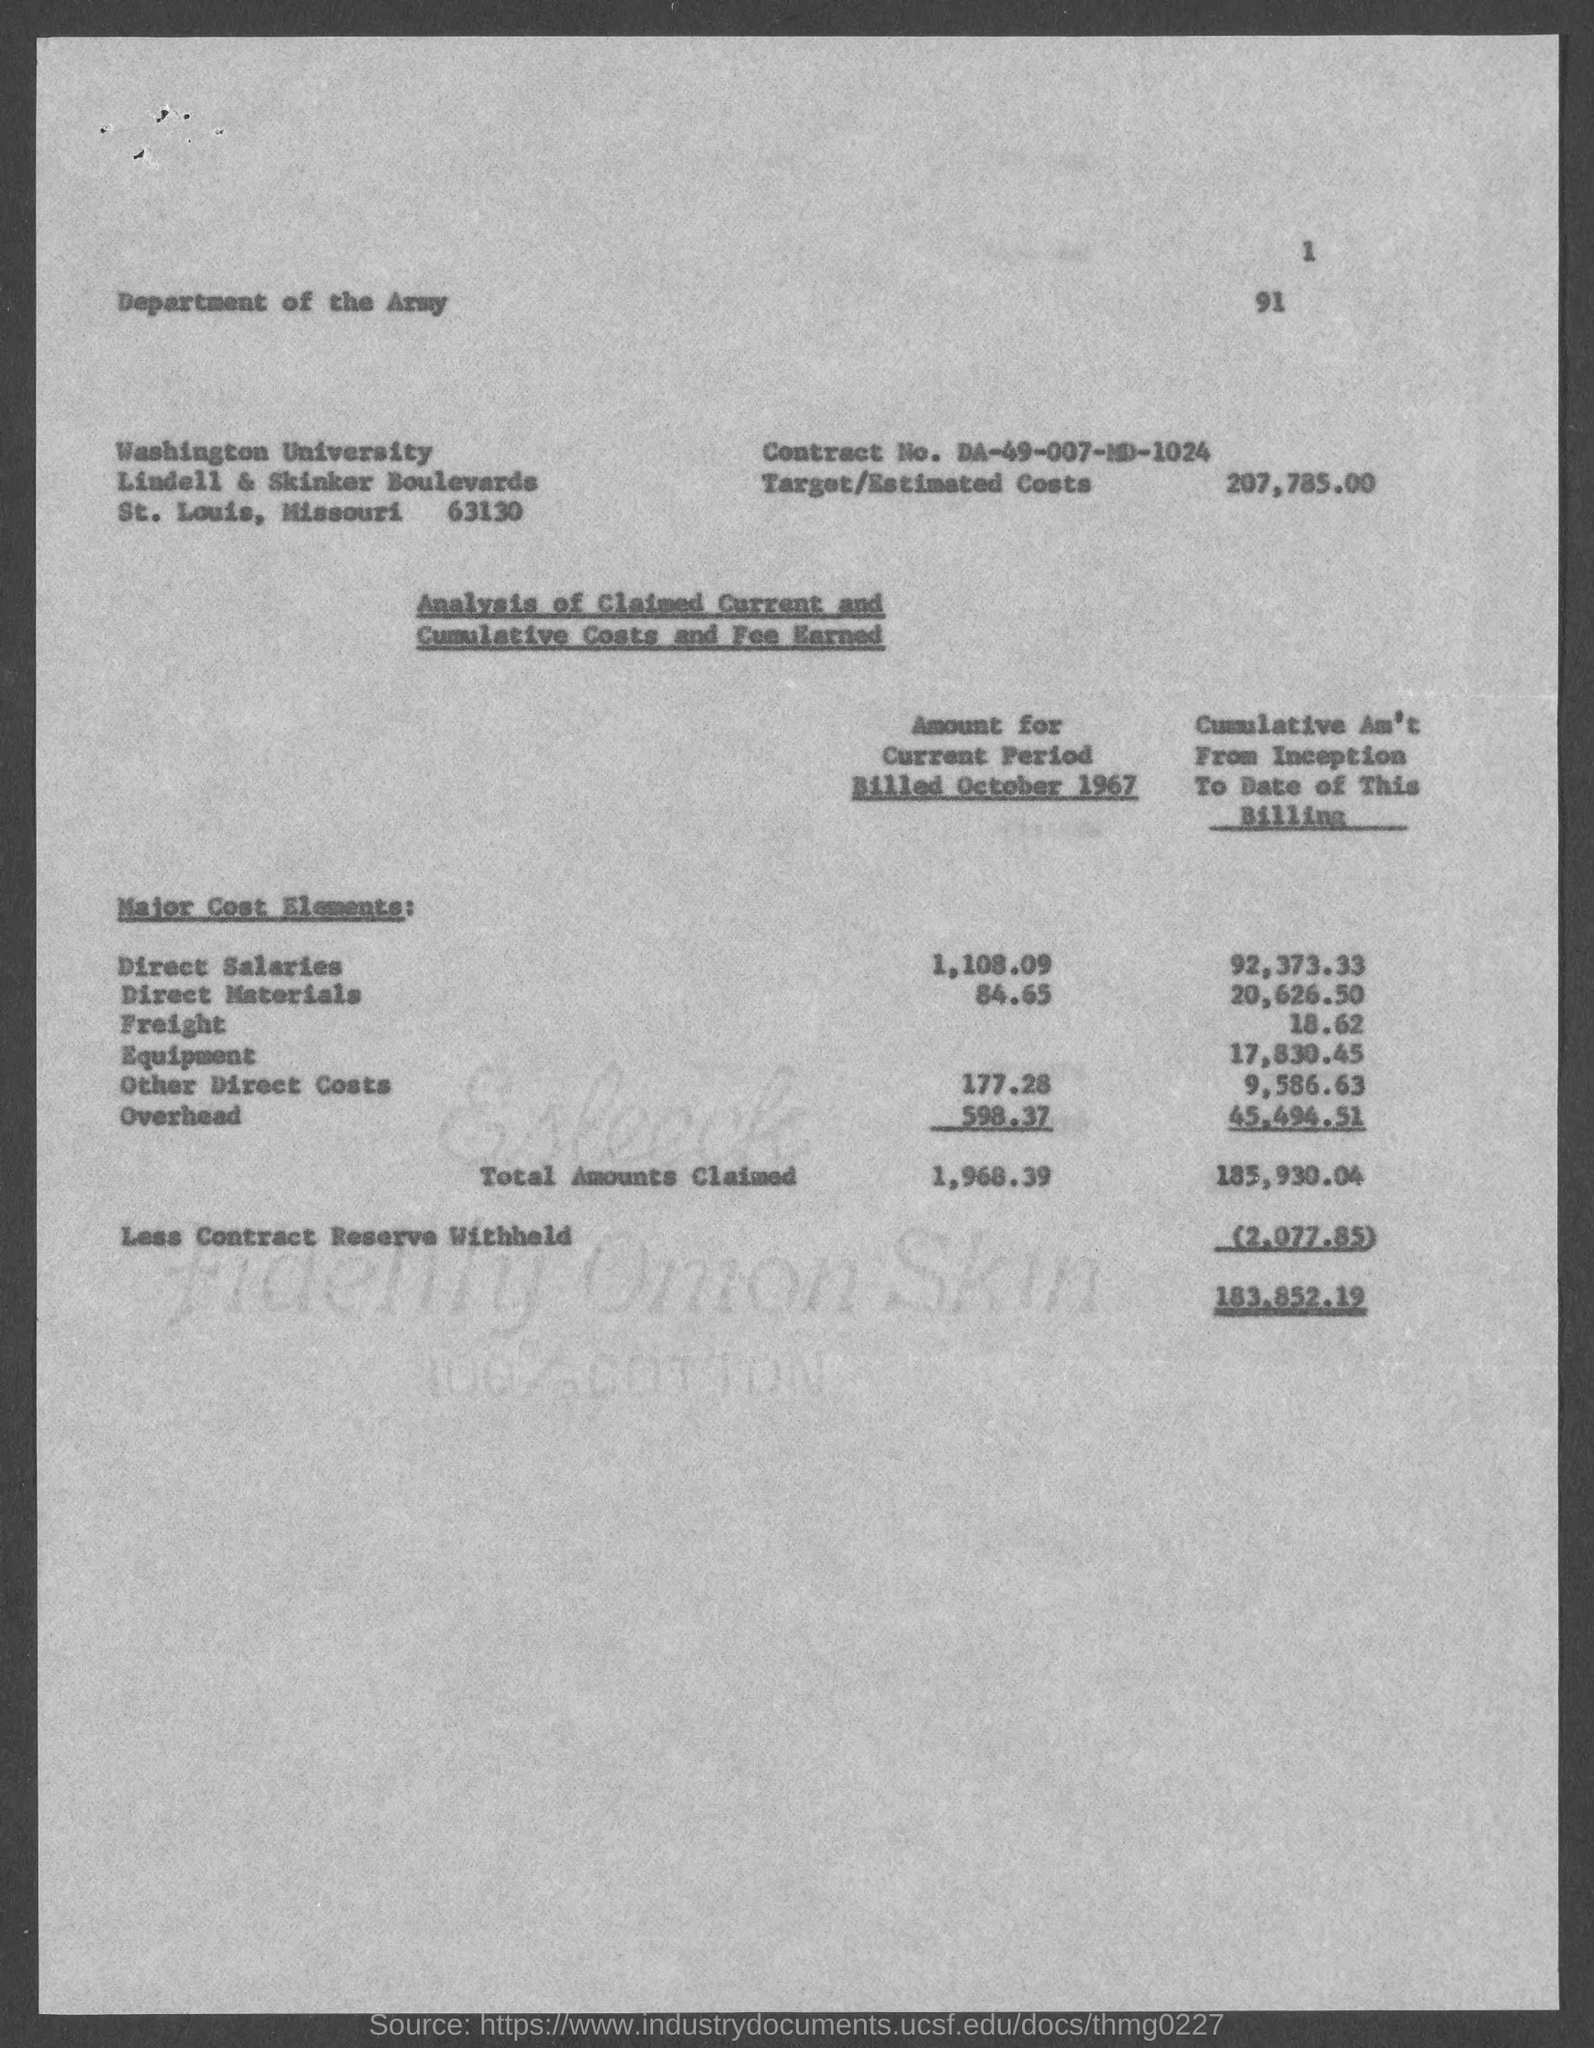Highlight a few significant elements in this photo. The estimated cost of the project is 207,785.00. The contract number is DA-49-007-MD-1024. 